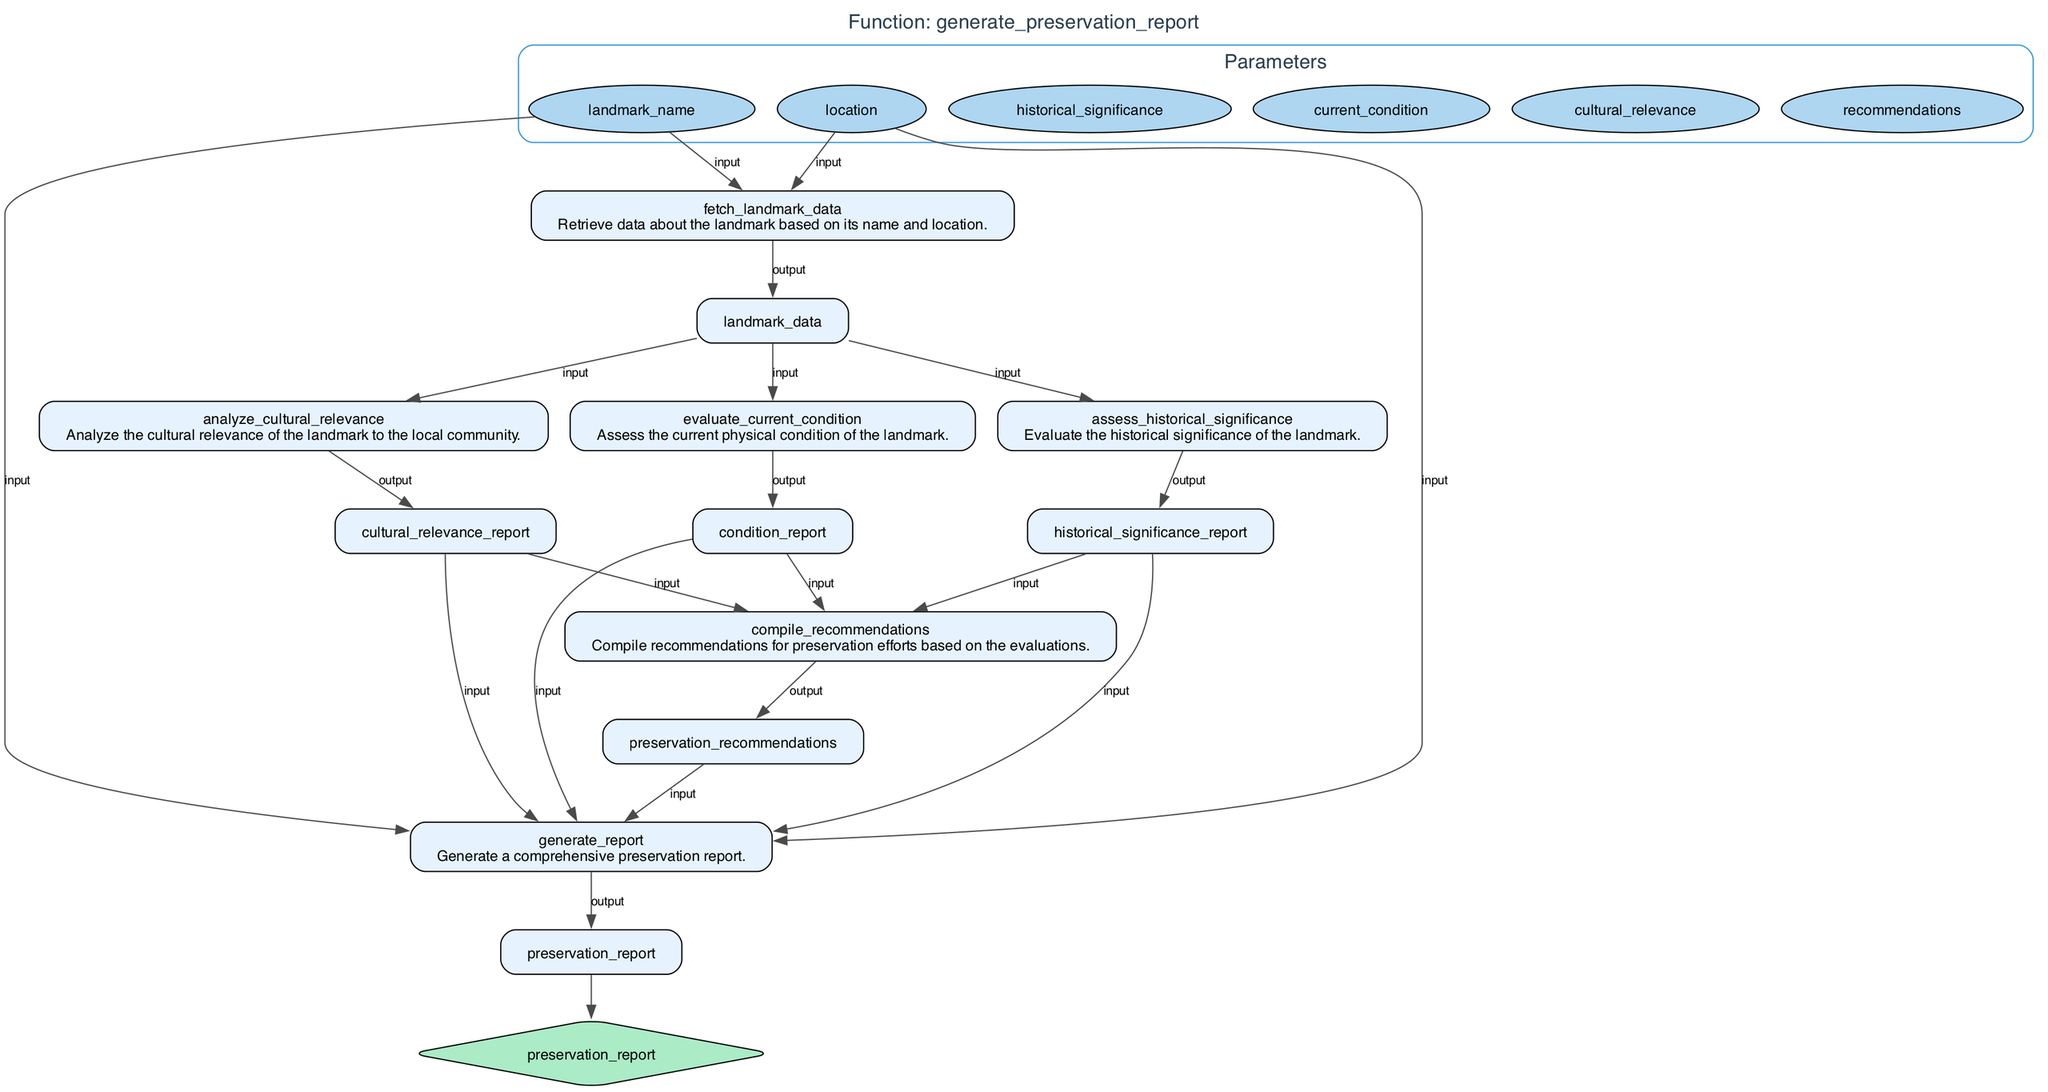What is the name of the function illustrated in the diagram? The function's name is provided at the top of the diagram, clearly labeled as "generate_preservation_report." This is indicated in the title of the flowchart.
Answer: generate preservation report How many input parameters does the function have? The diagram lists six input parameters under the Parameters section. Each parameter is represented as an ellipse. Counting these provides the total number of parameters.
Answer: six What is the output of the "generate_report" step? The output of the "generate_report" step is linked to the "preservation_report." This is shown as the final output node in the flowchart, which receives data from the previous step.
Answer: preservation report What is the first step in the process of generating a preservation report? The first step is labeled "fetch_landmark_data," described as retrieving data about the landmark based on its name and location. This initiates the sequence leading to the report generation.
Answer: fetch landmark data Which evaluation occurs after analyzing cultural relevance? The flowchart indicates that the step directly after "analyze_cultural_relevance" is "compile_recommendations." This shows the progression to compiling preservation recommendations based on earlier evaluations.
Answer: compile recommendations How many types of evaluations are conducted in this process? Three evaluations are conducted: assessing historical significance, evaluating current condition, and analyzing cultural relevance. Each is represented as a separate step in the flowchart.
Answer: three What is the role of the "fetch_landmark_data" step? This step's role is to retrieve the necessary data about the landmark based on its name and location as shown in the description next to the step's label.
Answer: retrieve data What types of reports are generated before compiling recommendations? The reports generated are: historical_significance_report, condition_report, and cultural_relevance_report. Each of these reports is outputs from their respective evaluation steps and used in the recommendations compilation.
Answer: historical significance report, condition report, cultural relevance report What does the final output node of the diagram represent? The final output node "preservation_report" represents the comprehensive preservation report generated as the ultimate outcome of all previous steps in the function.
Answer: preservation report 